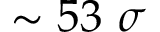Convert formula to latex. <formula><loc_0><loc_0><loc_500><loc_500>\sim 5 3 \sigma</formula> 